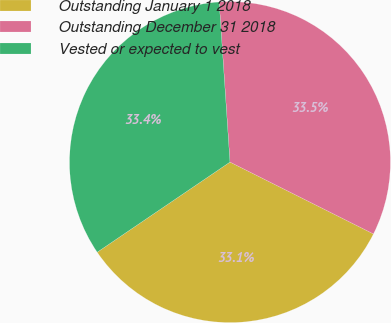<chart> <loc_0><loc_0><loc_500><loc_500><pie_chart><fcel>Outstanding January 1 2018<fcel>Outstanding December 31 2018<fcel>Vested or expected to vest<nl><fcel>33.12%<fcel>33.46%<fcel>33.42%<nl></chart> 